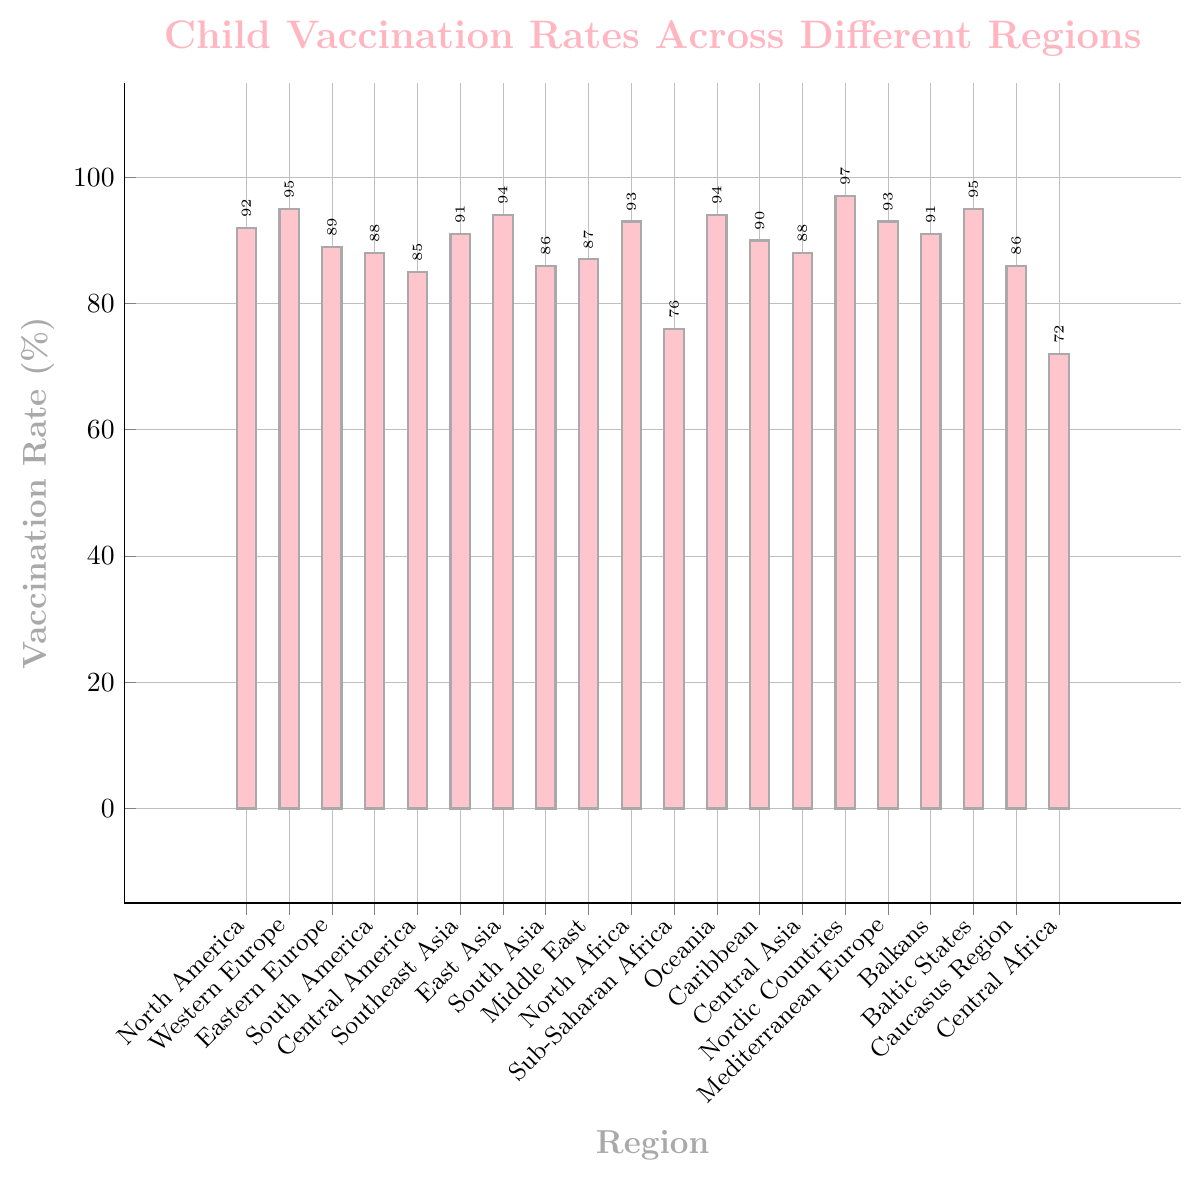What region has the highest child vaccination rate? The bar representing the child vaccination rates shows that the Nordic Countries have the highest value.
Answer: Nordic Countries What region has the lowest child vaccination rate? By observing the height of the bars, Central Africa has the lowest child vaccination rate.
Answer: Central Africa How many regions have a vaccination rate of 90% or higher? Inspecting the bars that reach 90% or more, the regions are North America, Western Europe, Southeast Asia, East Asia, North Africa, Oceania, Baltic States, and Nordic Countries. There are 8 regions in total.
Answer: 8 Compare the vaccination rates of the Middle East and the Mediterranean Europe. Which one is higher? The Middle East has a vaccination rate of 87% while the Mediterranean Europe has a rate of 93%. Therefore, Mediterranean Europe is higher.
Answer: Mediterranean Europe What is the average vaccination rate across all regions? Adding all the percentages and dividing by the number of regions: (92 + 95 + 89 + 88 + 85 + 91 + 94 + 86 + 87 + 93 + 76 + 94 + 90 + 88 + 97 + 93 + 91 + 95 + 86 + 72) / 20 = 89.2%
Answer: 89.2% Which regions have child vaccination rates between 85% and 90%? Reviewing the bars within the range of 85% to 90%, the regions are Eastern Europe, South America, Central America, South Asia, Middle East, Caribbean, Central Asia, and Caucasus Region.
Answer: Eastern Europe, South America, Central America, South Asia, Middle East, Caribbean, Central Asia, Caucasus Region By how much does the vaccination rate in Sub-Saharan Africa fall short of the global average vaccination rate? The global average is 89.2%, and Sub-Saharan Africa has 76%. The difference is 89.2 - 76 = 13.2%.
Answer: 13.2% Which two regions have the closest vaccination rates, and what is the difference? Eastern Europe (89%) and South America (88%) have the closest rates with a difference of 1%.
Answer: Eastern Europe and South America, 1% Compare the vaccination rates in North America and South America. What is the difference? North America has a vaccination rate of 92% and South America has 88%. The difference is 92 - 88 = 4%.
Answer: 4% Which regions have a vaccination rate higher than 90% but less than 95%? The regions with capacities greater than 90% but less than 95% are North America, Southeast Asia, East Asia, North Africa, Oceania, and Balkans.
Answer: North America, Southeast Asia, East Asia, North Africa, Oceania, Balkans 